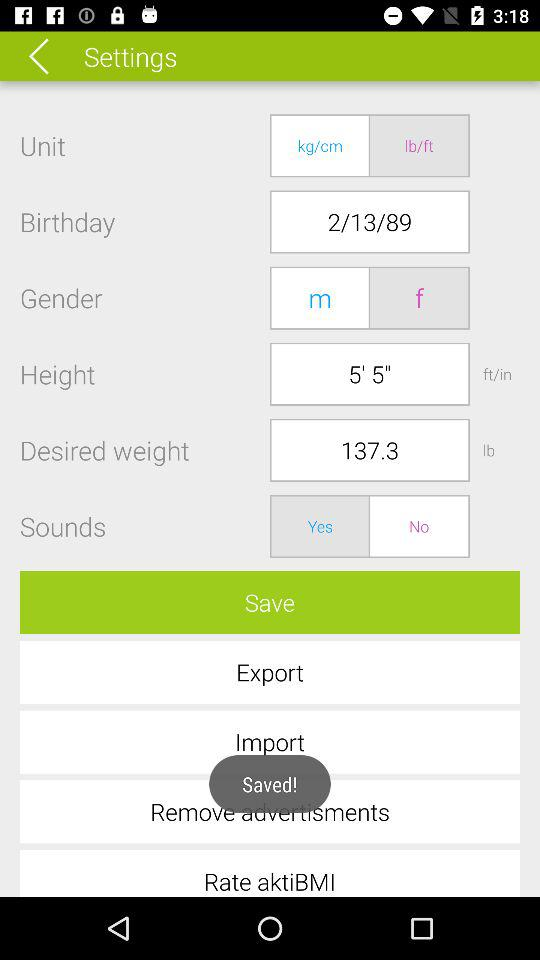What is the height? The height is 5' 5". 